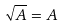Convert formula to latex. <formula><loc_0><loc_0><loc_500><loc_500>\sqrt { A } = A</formula> 